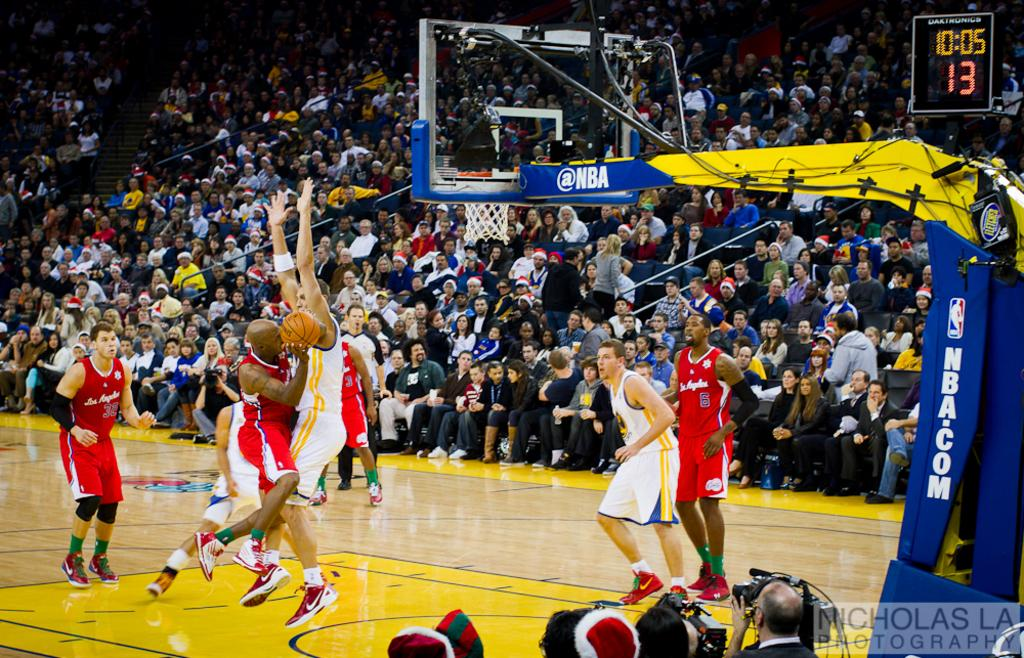Provide a one-sentence caption for the provided image. A player for Los Angeles' basketball team attempts to take a shot. 